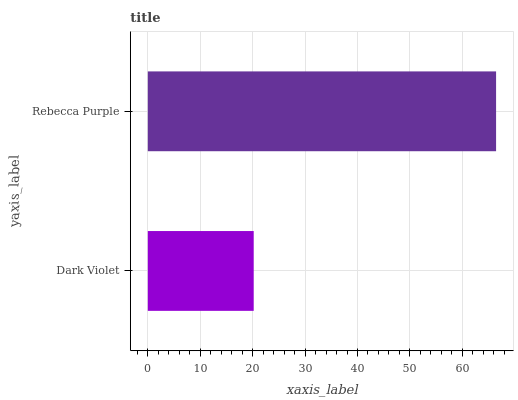Is Dark Violet the minimum?
Answer yes or no. Yes. Is Rebecca Purple the maximum?
Answer yes or no. Yes. Is Rebecca Purple the minimum?
Answer yes or no. No. Is Rebecca Purple greater than Dark Violet?
Answer yes or no. Yes. Is Dark Violet less than Rebecca Purple?
Answer yes or no. Yes. Is Dark Violet greater than Rebecca Purple?
Answer yes or no. No. Is Rebecca Purple less than Dark Violet?
Answer yes or no. No. Is Rebecca Purple the high median?
Answer yes or no. Yes. Is Dark Violet the low median?
Answer yes or no. Yes. Is Dark Violet the high median?
Answer yes or no. No. Is Rebecca Purple the low median?
Answer yes or no. No. 